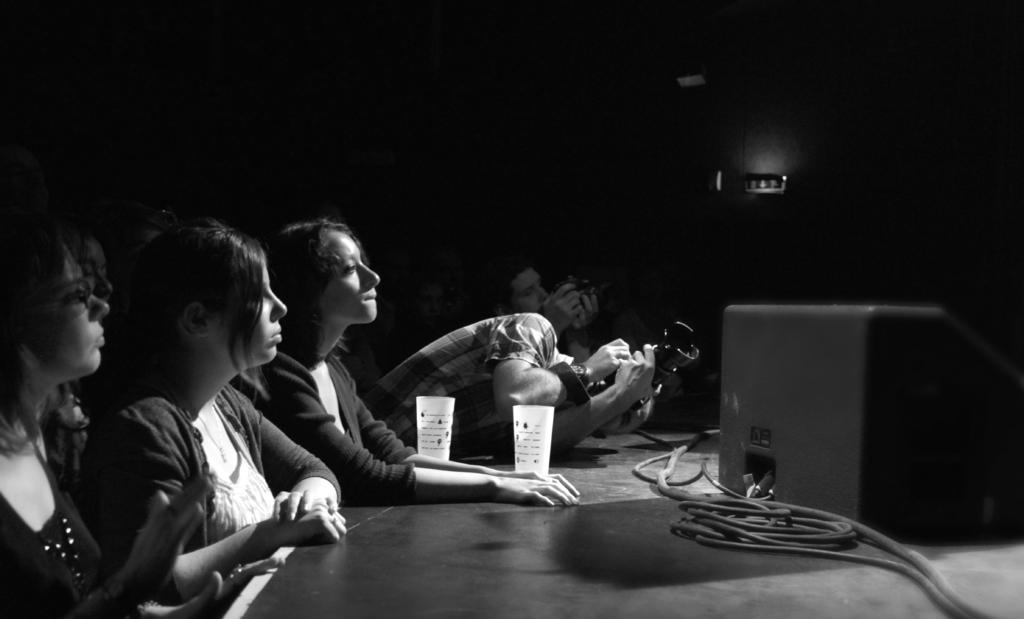What are the people in the image doing? There is a group of people seated in the image. Can you describe the man in the image? The man is holding a camera in the image. What objects are on the table in the image? There are cups on a table in the image. What type of scent can be detected from the army in the image? There is no army present in the image, so it is not possible to detect any scent. 